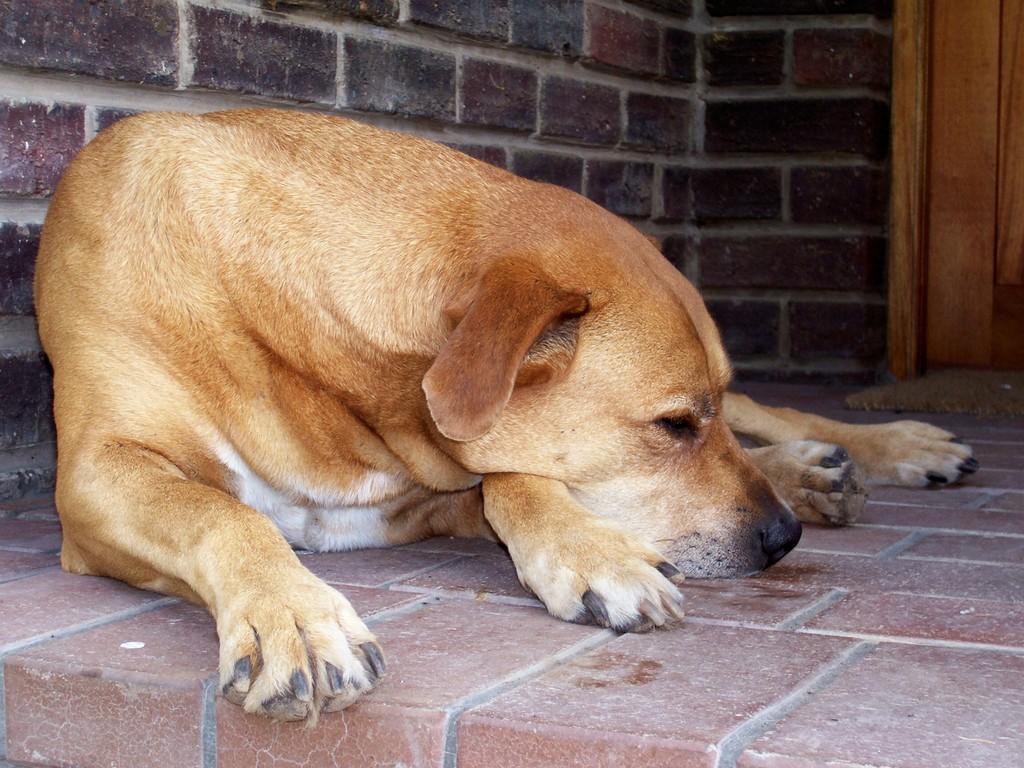Describe this image in one or two sentences. In this picture there is a dog in the center of the image and there is a door in the background area of the image. 